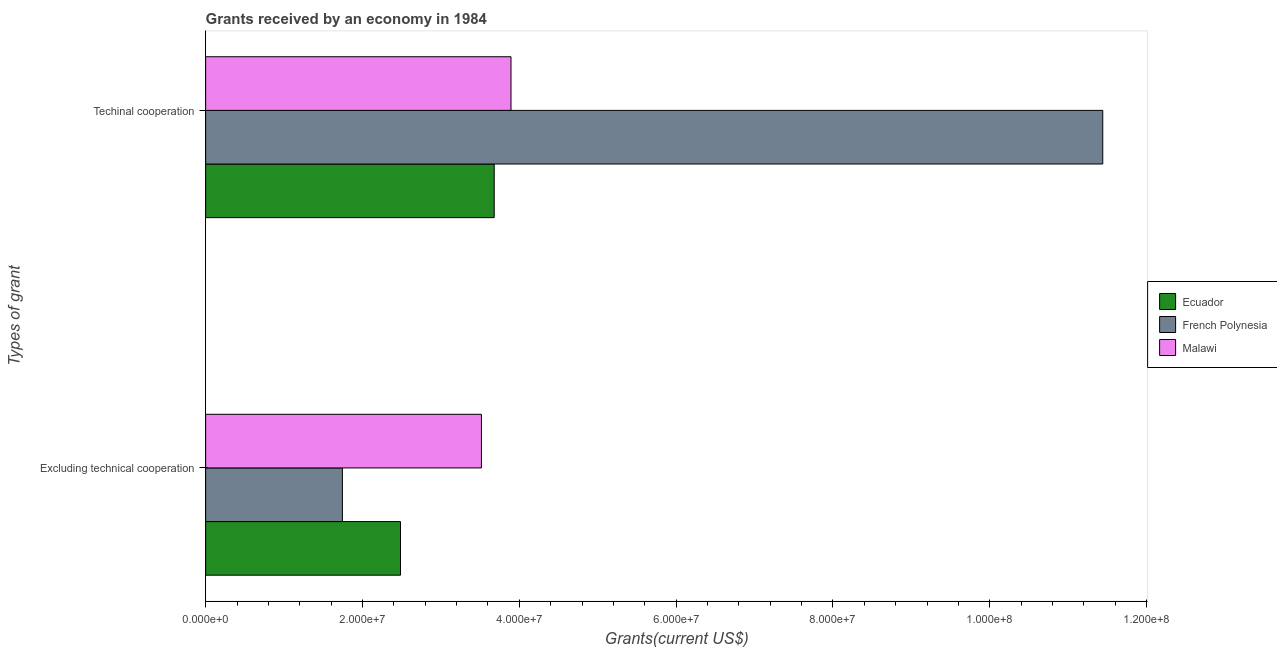Are the number of bars per tick equal to the number of legend labels?
Make the answer very short. Yes. Are the number of bars on each tick of the Y-axis equal?
Provide a succinct answer. Yes. How many bars are there on the 2nd tick from the top?
Ensure brevity in your answer.  3. What is the label of the 1st group of bars from the top?
Your answer should be compact. Techinal cooperation. What is the amount of grants received(excluding technical cooperation) in Ecuador?
Provide a short and direct response. 2.48e+07. Across all countries, what is the maximum amount of grants received(excluding technical cooperation)?
Provide a succinct answer. 3.52e+07. Across all countries, what is the minimum amount of grants received(excluding technical cooperation)?
Your answer should be very brief. 1.74e+07. In which country was the amount of grants received(excluding technical cooperation) maximum?
Provide a short and direct response. Malawi. In which country was the amount of grants received(excluding technical cooperation) minimum?
Your answer should be very brief. French Polynesia. What is the total amount of grants received(including technical cooperation) in the graph?
Give a very brief answer. 1.90e+08. What is the difference between the amount of grants received(including technical cooperation) in French Polynesia and that in Ecuador?
Provide a succinct answer. 7.76e+07. What is the difference between the amount of grants received(excluding technical cooperation) in Malawi and the amount of grants received(including technical cooperation) in Ecuador?
Make the answer very short. -1.63e+06. What is the average amount of grants received(excluding technical cooperation) per country?
Your answer should be compact. 2.58e+07. What is the difference between the amount of grants received(including technical cooperation) and amount of grants received(excluding technical cooperation) in Malawi?
Ensure brevity in your answer.  3.77e+06. In how many countries, is the amount of grants received(including technical cooperation) greater than 28000000 US$?
Ensure brevity in your answer.  3. What is the ratio of the amount of grants received(including technical cooperation) in French Polynesia to that in Ecuador?
Give a very brief answer. 3.11. What does the 3rd bar from the top in Excluding technical cooperation represents?
Offer a terse response. Ecuador. What does the 3rd bar from the bottom in Techinal cooperation represents?
Your answer should be compact. Malawi. How many bars are there?
Provide a succinct answer. 6. How many countries are there in the graph?
Offer a terse response. 3. Are the values on the major ticks of X-axis written in scientific E-notation?
Your answer should be compact. Yes. Does the graph contain grids?
Give a very brief answer. No. How many legend labels are there?
Provide a short and direct response. 3. What is the title of the graph?
Ensure brevity in your answer.  Grants received by an economy in 1984. Does "St. Vincent and the Grenadines" appear as one of the legend labels in the graph?
Make the answer very short. No. What is the label or title of the X-axis?
Your answer should be very brief. Grants(current US$). What is the label or title of the Y-axis?
Your answer should be compact. Types of grant. What is the Grants(current US$) in Ecuador in Excluding technical cooperation?
Your answer should be compact. 2.48e+07. What is the Grants(current US$) in French Polynesia in Excluding technical cooperation?
Offer a very short reply. 1.74e+07. What is the Grants(current US$) in Malawi in Excluding technical cooperation?
Ensure brevity in your answer.  3.52e+07. What is the Grants(current US$) in Ecuador in Techinal cooperation?
Offer a very short reply. 3.68e+07. What is the Grants(current US$) of French Polynesia in Techinal cooperation?
Offer a terse response. 1.14e+08. What is the Grants(current US$) of Malawi in Techinal cooperation?
Offer a terse response. 3.89e+07. Across all Types of grant, what is the maximum Grants(current US$) of Ecuador?
Your answer should be very brief. 3.68e+07. Across all Types of grant, what is the maximum Grants(current US$) of French Polynesia?
Your answer should be very brief. 1.14e+08. Across all Types of grant, what is the maximum Grants(current US$) in Malawi?
Your answer should be very brief. 3.89e+07. Across all Types of grant, what is the minimum Grants(current US$) of Ecuador?
Your response must be concise. 2.48e+07. Across all Types of grant, what is the minimum Grants(current US$) in French Polynesia?
Provide a short and direct response. 1.74e+07. Across all Types of grant, what is the minimum Grants(current US$) of Malawi?
Provide a short and direct response. 3.52e+07. What is the total Grants(current US$) of Ecuador in the graph?
Provide a short and direct response. 6.16e+07. What is the total Grants(current US$) in French Polynesia in the graph?
Your response must be concise. 1.32e+08. What is the total Grants(current US$) in Malawi in the graph?
Offer a very short reply. 7.41e+07. What is the difference between the Grants(current US$) of Ecuador in Excluding technical cooperation and that in Techinal cooperation?
Ensure brevity in your answer.  -1.20e+07. What is the difference between the Grants(current US$) of French Polynesia in Excluding technical cooperation and that in Techinal cooperation?
Your answer should be very brief. -9.70e+07. What is the difference between the Grants(current US$) in Malawi in Excluding technical cooperation and that in Techinal cooperation?
Provide a succinct answer. -3.77e+06. What is the difference between the Grants(current US$) in Ecuador in Excluding technical cooperation and the Grants(current US$) in French Polynesia in Techinal cooperation?
Ensure brevity in your answer.  -8.96e+07. What is the difference between the Grants(current US$) of Ecuador in Excluding technical cooperation and the Grants(current US$) of Malawi in Techinal cooperation?
Your response must be concise. -1.41e+07. What is the difference between the Grants(current US$) in French Polynesia in Excluding technical cooperation and the Grants(current US$) in Malawi in Techinal cooperation?
Your response must be concise. -2.15e+07. What is the average Grants(current US$) in Ecuador per Types of grant?
Provide a succinct answer. 3.08e+07. What is the average Grants(current US$) in French Polynesia per Types of grant?
Keep it short and to the point. 6.59e+07. What is the average Grants(current US$) in Malawi per Types of grant?
Offer a very short reply. 3.71e+07. What is the difference between the Grants(current US$) in Ecuador and Grants(current US$) in French Polynesia in Excluding technical cooperation?
Give a very brief answer. 7.41e+06. What is the difference between the Grants(current US$) of Ecuador and Grants(current US$) of Malawi in Excluding technical cooperation?
Give a very brief answer. -1.03e+07. What is the difference between the Grants(current US$) in French Polynesia and Grants(current US$) in Malawi in Excluding technical cooperation?
Keep it short and to the point. -1.77e+07. What is the difference between the Grants(current US$) of Ecuador and Grants(current US$) of French Polynesia in Techinal cooperation?
Give a very brief answer. -7.76e+07. What is the difference between the Grants(current US$) of Ecuador and Grants(current US$) of Malawi in Techinal cooperation?
Make the answer very short. -2.14e+06. What is the difference between the Grants(current US$) of French Polynesia and Grants(current US$) of Malawi in Techinal cooperation?
Your answer should be compact. 7.55e+07. What is the ratio of the Grants(current US$) in Ecuador in Excluding technical cooperation to that in Techinal cooperation?
Your answer should be compact. 0.68. What is the ratio of the Grants(current US$) in French Polynesia in Excluding technical cooperation to that in Techinal cooperation?
Your answer should be very brief. 0.15. What is the ratio of the Grants(current US$) in Malawi in Excluding technical cooperation to that in Techinal cooperation?
Offer a terse response. 0.9. What is the difference between the highest and the second highest Grants(current US$) in Ecuador?
Your answer should be very brief. 1.20e+07. What is the difference between the highest and the second highest Grants(current US$) in French Polynesia?
Your answer should be compact. 9.70e+07. What is the difference between the highest and the second highest Grants(current US$) of Malawi?
Ensure brevity in your answer.  3.77e+06. What is the difference between the highest and the lowest Grants(current US$) of Ecuador?
Offer a very short reply. 1.20e+07. What is the difference between the highest and the lowest Grants(current US$) of French Polynesia?
Your response must be concise. 9.70e+07. What is the difference between the highest and the lowest Grants(current US$) of Malawi?
Offer a terse response. 3.77e+06. 